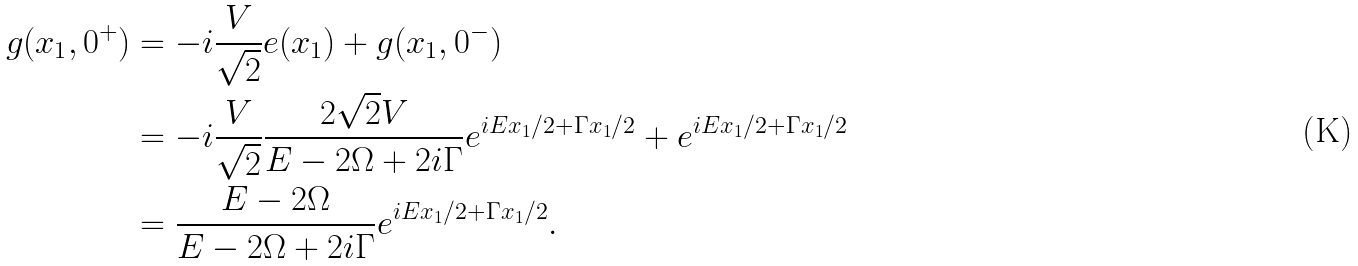<formula> <loc_0><loc_0><loc_500><loc_500>g ( x _ { 1 } , 0 ^ { + } ) & = - i \frac { V } { \sqrt { 2 } } e ( x _ { 1 } ) + g ( x _ { 1 } , 0 ^ { - } ) \\ & = - i \frac { V } { \sqrt { 2 } } \frac { 2 \sqrt { 2 } V } { E - 2 \Omega + 2 i \Gamma } e ^ { i E x _ { 1 } / 2 + \Gamma x _ { 1 } / 2 } + e ^ { i E x _ { 1 } / 2 + \Gamma x _ { 1 } / 2 } \\ & = \frac { E - 2 \Omega } { E - 2 \Omega + 2 i \Gamma } e ^ { i E x _ { 1 } / 2 + \Gamma x _ { 1 } / 2 } .</formula> 